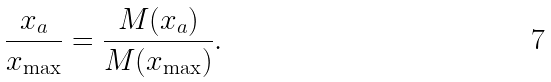Convert formula to latex. <formula><loc_0><loc_0><loc_500><loc_500>\frac { x _ { a } } { x _ { \max } } = \frac { M ( x _ { a } ) } { M ( x _ { \max } ) } .</formula> 